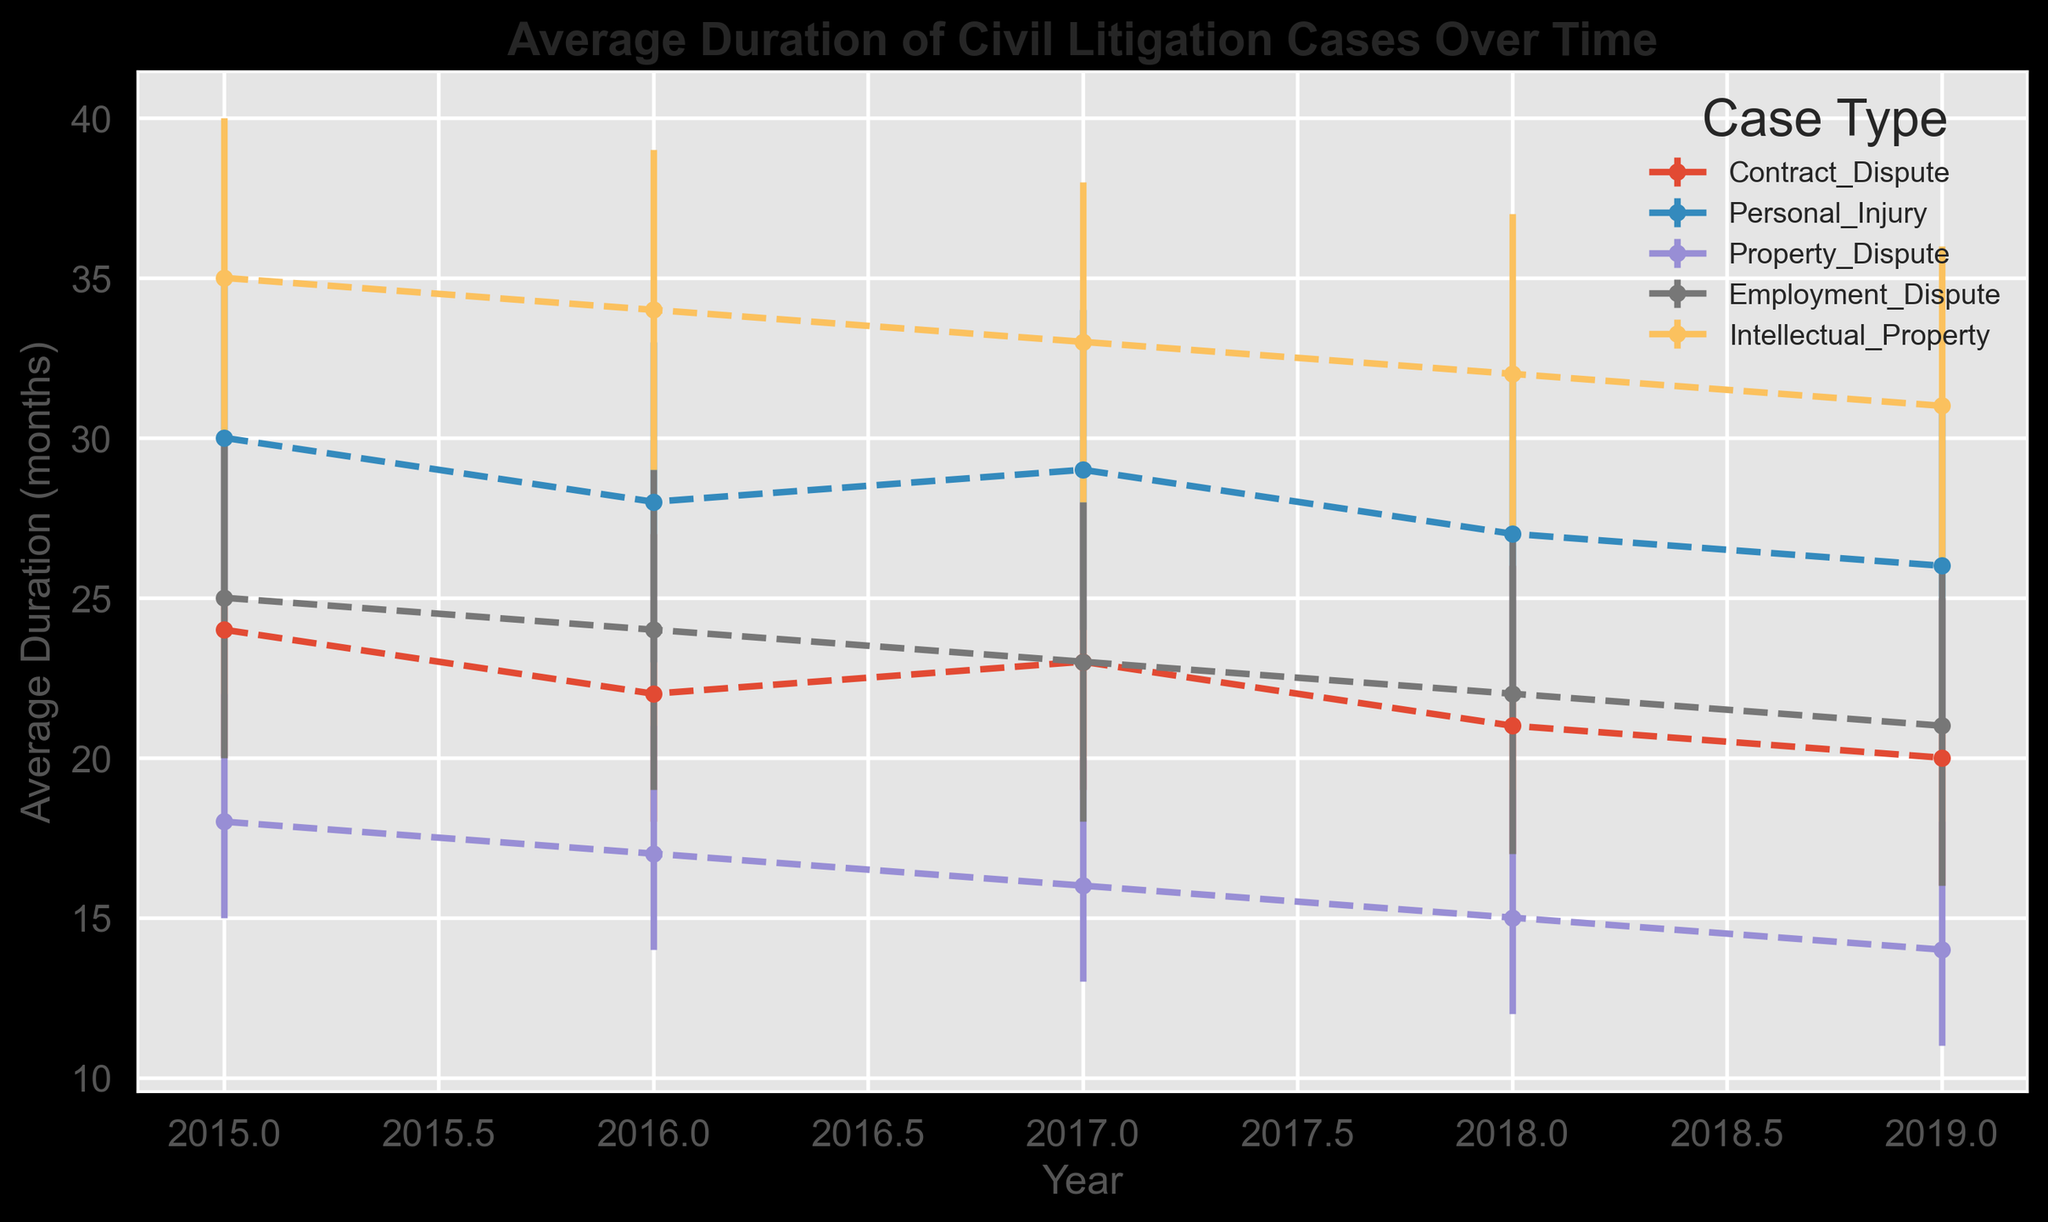What's the case type with the highest average duration in 2019? Look at the data points for 2019 and compare their heights. The highest point is for Intellectual Property as its average duration is 31 months.
Answer: Intellectual Property What's the overall trend for Contract Dispute cases from 2015 to 2019? Observe the line representing Contract Dispute cases. It shows a decreasing trend as the average duration decreases from 24 months in 2015 to 20 months in 2019.
Answer: Decreasing Which year shows the maximum error range for Personal Injury cases? Compare the error bars for Personal Injury cases across all years. The longest error bar is in 2015, where the error range is [25, 35].
Answer: 2015 What's the average duration of civil litigation cases for Employment Dispute and Property Dispute in 2017? Check the average duration values for Employment Dispute and Property Dispute in 2017. Employment Dispute has 23 months and Property Dispute has 16 months. Taking their average: (23+16)/2 = 19.5 months.
Answer: 19.5 months Which case type shows a consistent decrease in average duration from 2015 to 2019? Examine the lines for each case type. Property Dispute consistently decreases from 18 months in 2015 to 14 months in 2019.
Answer: Property Dispute How does the average duration of Intellectual Property cases in 2016 compare to Contract Dispute cases in 2016? Look at the average duration values for both case types in 2016. Intellectual Property has 34 months, and Contract Dispute has 22 months. Intellectual Property is longer.
Answer: Intellectual Property is longer What is the difference in average duration between Personal Injury and Employment Dispute cases in 2018? Find the average durations for both case types in 2018. Personal Injury is 27 months, Employment Dispute is 22 months. The difference is 27 - 22 = 5 months.
Answer: 5 months Which case type has the smallest error range in 2019? Compare the error ranges for all case types in 2019. Property Dispute has the smallest range, with an error range [11, 18] and a duration of 14 months. The total error range is 7 months.
Answer: Property Dispute Which case type's average duration most rapidly decreases from 2015 to 2019? Determine the decrease for each case type over the years. Intellectual Property decreases from 35 to 31, a difference of 4 months. Employment Dispute decreases from 25 to 21, a difference of 4 months. Personal Injury decreases from 30 to 26, a difference of 4. Contract Dispute decreases from 24 to 20, a difference of 4 months. Property Dispute decreases from 18 to 14, a difference of 4 months. Since all decreases are the same, there is no single most rapid decrease.
Answer: All case types decrease equally What is the average of the upper bound durations for Personal Injury cases from 2015 to 2019? Calculate the upper bounds for each year: 2015 (35), 2016 (33), 2017 (34), 2018 (32), 2019 (31). Sum these values (35 + 33 + 34 + 32 + 31 = 165) and divide by 5 (165 / 5 = 33 months).
Answer: 33 months 